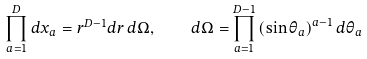Convert formula to latex. <formula><loc_0><loc_0><loc_500><loc_500>\prod _ { a = 1 } ^ { D } d x _ { a } = r ^ { D - 1 } d r \, d \Omega , \quad d \Omega = \prod _ { a = 1 } ^ { D - 1 } \left ( \sin \theta _ { a } \right ) ^ { a - 1 } d \theta _ { a }</formula> 